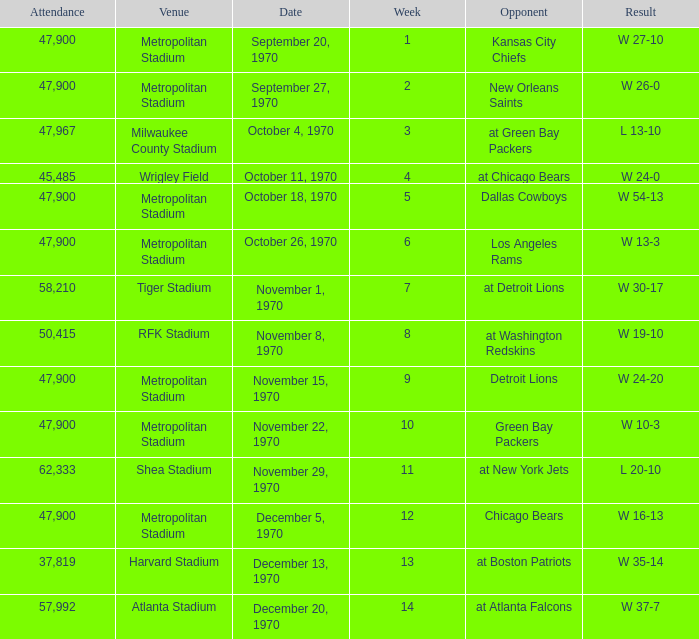How many people attended the game with a result of w 16-13 and a week earlier than 12? None. 